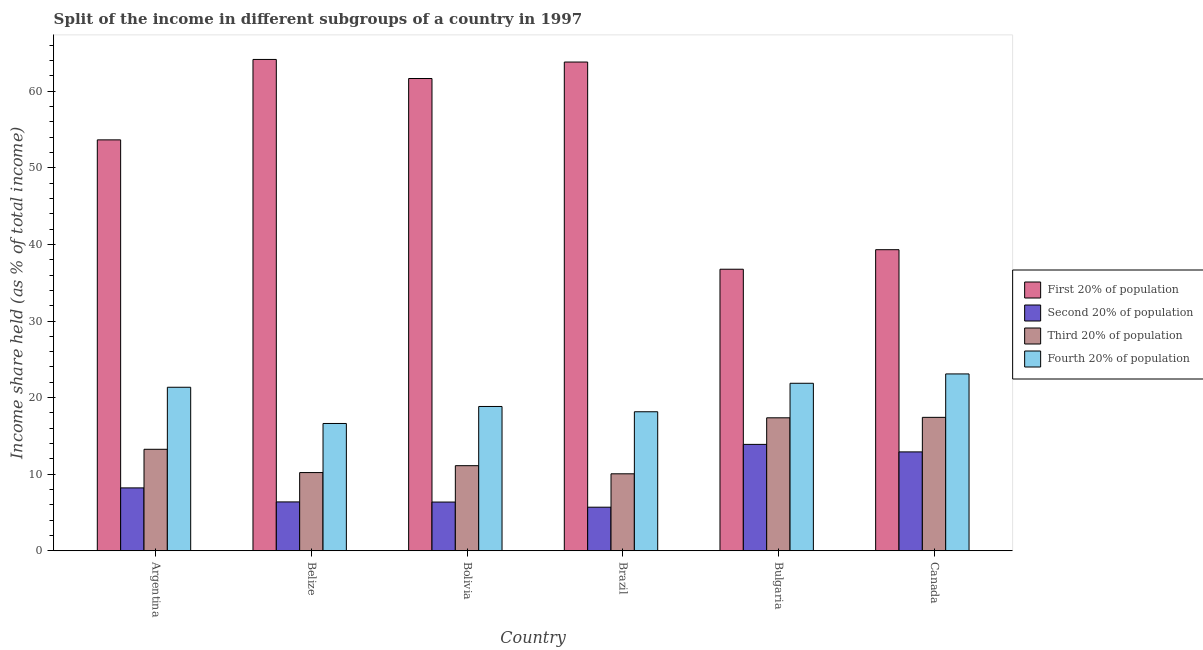How many different coloured bars are there?
Provide a succinct answer. 4. How many groups of bars are there?
Your answer should be compact. 6. How many bars are there on the 5th tick from the right?
Offer a very short reply. 4. What is the share of the income held by first 20% of the population in Brazil?
Ensure brevity in your answer.  63.81. Across all countries, what is the maximum share of the income held by fourth 20% of the population?
Ensure brevity in your answer.  23.09. Across all countries, what is the minimum share of the income held by third 20% of the population?
Your answer should be very brief. 10.05. What is the total share of the income held by third 20% of the population in the graph?
Keep it short and to the point. 79.4. What is the difference between the share of the income held by first 20% of the population in Argentina and that in Bulgaria?
Provide a succinct answer. 16.89. What is the difference between the share of the income held by fourth 20% of the population in Argentina and the share of the income held by third 20% of the population in Canada?
Provide a succinct answer. 3.93. What is the average share of the income held by first 20% of the population per country?
Keep it short and to the point. 53.22. What is the difference between the share of the income held by third 20% of the population and share of the income held by fourth 20% of the population in Bulgaria?
Ensure brevity in your answer.  -4.51. In how many countries, is the share of the income held by third 20% of the population greater than 50 %?
Your response must be concise. 0. What is the ratio of the share of the income held by third 20% of the population in Belize to that in Canada?
Your response must be concise. 0.59. What is the difference between the highest and the second highest share of the income held by fourth 20% of the population?
Your answer should be very brief. 1.22. What is the difference between the highest and the lowest share of the income held by third 20% of the population?
Your answer should be very brief. 7.37. In how many countries, is the share of the income held by first 20% of the population greater than the average share of the income held by first 20% of the population taken over all countries?
Offer a very short reply. 4. Is the sum of the share of the income held by fourth 20% of the population in Argentina and Brazil greater than the maximum share of the income held by third 20% of the population across all countries?
Make the answer very short. Yes. What does the 3rd bar from the left in Belize represents?
Make the answer very short. Third 20% of population. What does the 4th bar from the right in Canada represents?
Your answer should be compact. First 20% of population. Is it the case that in every country, the sum of the share of the income held by first 20% of the population and share of the income held by second 20% of the population is greater than the share of the income held by third 20% of the population?
Provide a short and direct response. Yes. Are all the bars in the graph horizontal?
Give a very brief answer. No. How many countries are there in the graph?
Your response must be concise. 6. What is the difference between two consecutive major ticks on the Y-axis?
Make the answer very short. 10. Are the values on the major ticks of Y-axis written in scientific E-notation?
Offer a terse response. No. Does the graph contain any zero values?
Offer a very short reply. No. Does the graph contain grids?
Keep it short and to the point. No. Where does the legend appear in the graph?
Keep it short and to the point. Center right. How many legend labels are there?
Give a very brief answer. 4. How are the legend labels stacked?
Offer a terse response. Vertical. What is the title of the graph?
Your answer should be compact. Split of the income in different subgroups of a country in 1997. Does "Luxembourg" appear as one of the legend labels in the graph?
Your answer should be very brief. No. What is the label or title of the Y-axis?
Make the answer very short. Income share held (as % of total income). What is the Income share held (as % of total income) of First 20% of population in Argentina?
Provide a succinct answer. 53.65. What is the Income share held (as % of total income) in Second 20% of population in Argentina?
Make the answer very short. 8.21. What is the Income share held (as % of total income) in Third 20% of population in Argentina?
Keep it short and to the point. 13.25. What is the Income share held (as % of total income) in Fourth 20% of population in Argentina?
Offer a very short reply. 21.35. What is the Income share held (as % of total income) in First 20% of population in Belize?
Provide a succinct answer. 64.15. What is the Income share held (as % of total income) of Second 20% of population in Belize?
Offer a terse response. 6.38. What is the Income share held (as % of total income) of Third 20% of population in Belize?
Keep it short and to the point. 10.21. What is the Income share held (as % of total income) in Fourth 20% of population in Belize?
Ensure brevity in your answer.  16.62. What is the Income share held (as % of total income) of First 20% of population in Bolivia?
Offer a very short reply. 61.66. What is the Income share held (as % of total income) in Second 20% of population in Bolivia?
Your answer should be compact. 6.36. What is the Income share held (as % of total income) in Third 20% of population in Bolivia?
Offer a very short reply. 11.11. What is the Income share held (as % of total income) in Fourth 20% of population in Bolivia?
Give a very brief answer. 18.84. What is the Income share held (as % of total income) in First 20% of population in Brazil?
Keep it short and to the point. 63.81. What is the Income share held (as % of total income) in Second 20% of population in Brazil?
Make the answer very short. 5.69. What is the Income share held (as % of total income) of Third 20% of population in Brazil?
Offer a very short reply. 10.05. What is the Income share held (as % of total income) in Fourth 20% of population in Brazil?
Your answer should be very brief. 18.15. What is the Income share held (as % of total income) in First 20% of population in Bulgaria?
Offer a very short reply. 36.76. What is the Income share held (as % of total income) in Second 20% of population in Bulgaria?
Make the answer very short. 13.89. What is the Income share held (as % of total income) in Third 20% of population in Bulgaria?
Provide a succinct answer. 17.36. What is the Income share held (as % of total income) of Fourth 20% of population in Bulgaria?
Give a very brief answer. 21.87. What is the Income share held (as % of total income) in First 20% of population in Canada?
Your answer should be compact. 39.31. What is the Income share held (as % of total income) in Second 20% of population in Canada?
Offer a terse response. 12.91. What is the Income share held (as % of total income) of Third 20% of population in Canada?
Your answer should be compact. 17.42. What is the Income share held (as % of total income) of Fourth 20% of population in Canada?
Offer a very short reply. 23.09. Across all countries, what is the maximum Income share held (as % of total income) of First 20% of population?
Keep it short and to the point. 64.15. Across all countries, what is the maximum Income share held (as % of total income) in Second 20% of population?
Your answer should be very brief. 13.89. Across all countries, what is the maximum Income share held (as % of total income) in Third 20% of population?
Your answer should be very brief. 17.42. Across all countries, what is the maximum Income share held (as % of total income) of Fourth 20% of population?
Ensure brevity in your answer.  23.09. Across all countries, what is the minimum Income share held (as % of total income) in First 20% of population?
Keep it short and to the point. 36.76. Across all countries, what is the minimum Income share held (as % of total income) in Second 20% of population?
Make the answer very short. 5.69. Across all countries, what is the minimum Income share held (as % of total income) in Third 20% of population?
Provide a short and direct response. 10.05. Across all countries, what is the minimum Income share held (as % of total income) in Fourth 20% of population?
Provide a succinct answer. 16.62. What is the total Income share held (as % of total income) of First 20% of population in the graph?
Your response must be concise. 319.34. What is the total Income share held (as % of total income) of Second 20% of population in the graph?
Your answer should be compact. 53.44. What is the total Income share held (as % of total income) in Third 20% of population in the graph?
Your response must be concise. 79.4. What is the total Income share held (as % of total income) of Fourth 20% of population in the graph?
Your answer should be compact. 119.92. What is the difference between the Income share held (as % of total income) in First 20% of population in Argentina and that in Belize?
Your answer should be compact. -10.5. What is the difference between the Income share held (as % of total income) in Second 20% of population in Argentina and that in Belize?
Provide a short and direct response. 1.83. What is the difference between the Income share held (as % of total income) of Third 20% of population in Argentina and that in Belize?
Your response must be concise. 3.04. What is the difference between the Income share held (as % of total income) in Fourth 20% of population in Argentina and that in Belize?
Keep it short and to the point. 4.73. What is the difference between the Income share held (as % of total income) in First 20% of population in Argentina and that in Bolivia?
Your response must be concise. -8.01. What is the difference between the Income share held (as % of total income) of Second 20% of population in Argentina and that in Bolivia?
Give a very brief answer. 1.85. What is the difference between the Income share held (as % of total income) of Third 20% of population in Argentina and that in Bolivia?
Keep it short and to the point. 2.14. What is the difference between the Income share held (as % of total income) in Fourth 20% of population in Argentina and that in Bolivia?
Give a very brief answer. 2.51. What is the difference between the Income share held (as % of total income) in First 20% of population in Argentina and that in Brazil?
Offer a terse response. -10.16. What is the difference between the Income share held (as % of total income) of Second 20% of population in Argentina and that in Brazil?
Offer a very short reply. 2.52. What is the difference between the Income share held (as % of total income) of First 20% of population in Argentina and that in Bulgaria?
Give a very brief answer. 16.89. What is the difference between the Income share held (as % of total income) in Second 20% of population in Argentina and that in Bulgaria?
Offer a very short reply. -5.68. What is the difference between the Income share held (as % of total income) in Third 20% of population in Argentina and that in Bulgaria?
Make the answer very short. -4.11. What is the difference between the Income share held (as % of total income) of Fourth 20% of population in Argentina and that in Bulgaria?
Give a very brief answer. -0.52. What is the difference between the Income share held (as % of total income) in First 20% of population in Argentina and that in Canada?
Your answer should be very brief. 14.34. What is the difference between the Income share held (as % of total income) in Third 20% of population in Argentina and that in Canada?
Keep it short and to the point. -4.17. What is the difference between the Income share held (as % of total income) in Fourth 20% of population in Argentina and that in Canada?
Your response must be concise. -1.74. What is the difference between the Income share held (as % of total income) in First 20% of population in Belize and that in Bolivia?
Ensure brevity in your answer.  2.49. What is the difference between the Income share held (as % of total income) in Fourth 20% of population in Belize and that in Bolivia?
Your answer should be compact. -2.22. What is the difference between the Income share held (as % of total income) of First 20% of population in Belize and that in Brazil?
Offer a very short reply. 0.34. What is the difference between the Income share held (as % of total income) of Second 20% of population in Belize and that in Brazil?
Your answer should be very brief. 0.69. What is the difference between the Income share held (as % of total income) in Third 20% of population in Belize and that in Brazil?
Make the answer very short. 0.16. What is the difference between the Income share held (as % of total income) in Fourth 20% of population in Belize and that in Brazil?
Offer a terse response. -1.53. What is the difference between the Income share held (as % of total income) in First 20% of population in Belize and that in Bulgaria?
Give a very brief answer. 27.39. What is the difference between the Income share held (as % of total income) of Second 20% of population in Belize and that in Bulgaria?
Give a very brief answer. -7.51. What is the difference between the Income share held (as % of total income) of Third 20% of population in Belize and that in Bulgaria?
Provide a short and direct response. -7.15. What is the difference between the Income share held (as % of total income) of Fourth 20% of population in Belize and that in Bulgaria?
Provide a short and direct response. -5.25. What is the difference between the Income share held (as % of total income) of First 20% of population in Belize and that in Canada?
Provide a short and direct response. 24.84. What is the difference between the Income share held (as % of total income) of Second 20% of population in Belize and that in Canada?
Offer a terse response. -6.53. What is the difference between the Income share held (as % of total income) in Third 20% of population in Belize and that in Canada?
Your response must be concise. -7.21. What is the difference between the Income share held (as % of total income) in Fourth 20% of population in Belize and that in Canada?
Keep it short and to the point. -6.47. What is the difference between the Income share held (as % of total income) of First 20% of population in Bolivia and that in Brazil?
Offer a very short reply. -2.15. What is the difference between the Income share held (as % of total income) of Second 20% of population in Bolivia and that in Brazil?
Your answer should be compact. 0.67. What is the difference between the Income share held (as % of total income) of Third 20% of population in Bolivia and that in Brazil?
Give a very brief answer. 1.06. What is the difference between the Income share held (as % of total income) in Fourth 20% of population in Bolivia and that in Brazil?
Keep it short and to the point. 0.69. What is the difference between the Income share held (as % of total income) of First 20% of population in Bolivia and that in Bulgaria?
Give a very brief answer. 24.9. What is the difference between the Income share held (as % of total income) of Second 20% of population in Bolivia and that in Bulgaria?
Offer a very short reply. -7.53. What is the difference between the Income share held (as % of total income) in Third 20% of population in Bolivia and that in Bulgaria?
Offer a very short reply. -6.25. What is the difference between the Income share held (as % of total income) of Fourth 20% of population in Bolivia and that in Bulgaria?
Keep it short and to the point. -3.03. What is the difference between the Income share held (as % of total income) of First 20% of population in Bolivia and that in Canada?
Your response must be concise. 22.35. What is the difference between the Income share held (as % of total income) of Second 20% of population in Bolivia and that in Canada?
Your answer should be compact. -6.55. What is the difference between the Income share held (as % of total income) of Third 20% of population in Bolivia and that in Canada?
Provide a succinct answer. -6.31. What is the difference between the Income share held (as % of total income) in Fourth 20% of population in Bolivia and that in Canada?
Provide a short and direct response. -4.25. What is the difference between the Income share held (as % of total income) in First 20% of population in Brazil and that in Bulgaria?
Offer a very short reply. 27.05. What is the difference between the Income share held (as % of total income) of Second 20% of population in Brazil and that in Bulgaria?
Ensure brevity in your answer.  -8.2. What is the difference between the Income share held (as % of total income) in Third 20% of population in Brazil and that in Bulgaria?
Give a very brief answer. -7.31. What is the difference between the Income share held (as % of total income) in Fourth 20% of population in Brazil and that in Bulgaria?
Your answer should be very brief. -3.72. What is the difference between the Income share held (as % of total income) of Second 20% of population in Brazil and that in Canada?
Make the answer very short. -7.22. What is the difference between the Income share held (as % of total income) of Third 20% of population in Brazil and that in Canada?
Provide a succinct answer. -7.37. What is the difference between the Income share held (as % of total income) in Fourth 20% of population in Brazil and that in Canada?
Provide a succinct answer. -4.94. What is the difference between the Income share held (as % of total income) of First 20% of population in Bulgaria and that in Canada?
Provide a short and direct response. -2.55. What is the difference between the Income share held (as % of total income) in Second 20% of population in Bulgaria and that in Canada?
Make the answer very short. 0.98. What is the difference between the Income share held (as % of total income) of Third 20% of population in Bulgaria and that in Canada?
Your answer should be compact. -0.06. What is the difference between the Income share held (as % of total income) in Fourth 20% of population in Bulgaria and that in Canada?
Provide a succinct answer. -1.22. What is the difference between the Income share held (as % of total income) of First 20% of population in Argentina and the Income share held (as % of total income) of Second 20% of population in Belize?
Offer a very short reply. 47.27. What is the difference between the Income share held (as % of total income) in First 20% of population in Argentina and the Income share held (as % of total income) in Third 20% of population in Belize?
Give a very brief answer. 43.44. What is the difference between the Income share held (as % of total income) in First 20% of population in Argentina and the Income share held (as % of total income) in Fourth 20% of population in Belize?
Offer a very short reply. 37.03. What is the difference between the Income share held (as % of total income) of Second 20% of population in Argentina and the Income share held (as % of total income) of Fourth 20% of population in Belize?
Your answer should be very brief. -8.41. What is the difference between the Income share held (as % of total income) of Third 20% of population in Argentina and the Income share held (as % of total income) of Fourth 20% of population in Belize?
Keep it short and to the point. -3.37. What is the difference between the Income share held (as % of total income) in First 20% of population in Argentina and the Income share held (as % of total income) in Second 20% of population in Bolivia?
Provide a succinct answer. 47.29. What is the difference between the Income share held (as % of total income) of First 20% of population in Argentina and the Income share held (as % of total income) of Third 20% of population in Bolivia?
Provide a succinct answer. 42.54. What is the difference between the Income share held (as % of total income) of First 20% of population in Argentina and the Income share held (as % of total income) of Fourth 20% of population in Bolivia?
Provide a short and direct response. 34.81. What is the difference between the Income share held (as % of total income) of Second 20% of population in Argentina and the Income share held (as % of total income) of Fourth 20% of population in Bolivia?
Offer a very short reply. -10.63. What is the difference between the Income share held (as % of total income) of Third 20% of population in Argentina and the Income share held (as % of total income) of Fourth 20% of population in Bolivia?
Your response must be concise. -5.59. What is the difference between the Income share held (as % of total income) of First 20% of population in Argentina and the Income share held (as % of total income) of Second 20% of population in Brazil?
Make the answer very short. 47.96. What is the difference between the Income share held (as % of total income) in First 20% of population in Argentina and the Income share held (as % of total income) in Third 20% of population in Brazil?
Your answer should be compact. 43.6. What is the difference between the Income share held (as % of total income) of First 20% of population in Argentina and the Income share held (as % of total income) of Fourth 20% of population in Brazil?
Offer a very short reply. 35.5. What is the difference between the Income share held (as % of total income) in Second 20% of population in Argentina and the Income share held (as % of total income) in Third 20% of population in Brazil?
Provide a short and direct response. -1.84. What is the difference between the Income share held (as % of total income) in Second 20% of population in Argentina and the Income share held (as % of total income) in Fourth 20% of population in Brazil?
Offer a terse response. -9.94. What is the difference between the Income share held (as % of total income) of Third 20% of population in Argentina and the Income share held (as % of total income) of Fourth 20% of population in Brazil?
Provide a succinct answer. -4.9. What is the difference between the Income share held (as % of total income) in First 20% of population in Argentina and the Income share held (as % of total income) in Second 20% of population in Bulgaria?
Keep it short and to the point. 39.76. What is the difference between the Income share held (as % of total income) in First 20% of population in Argentina and the Income share held (as % of total income) in Third 20% of population in Bulgaria?
Ensure brevity in your answer.  36.29. What is the difference between the Income share held (as % of total income) of First 20% of population in Argentina and the Income share held (as % of total income) of Fourth 20% of population in Bulgaria?
Offer a very short reply. 31.78. What is the difference between the Income share held (as % of total income) in Second 20% of population in Argentina and the Income share held (as % of total income) in Third 20% of population in Bulgaria?
Provide a succinct answer. -9.15. What is the difference between the Income share held (as % of total income) of Second 20% of population in Argentina and the Income share held (as % of total income) of Fourth 20% of population in Bulgaria?
Give a very brief answer. -13.66. What is the difference between the Income share held (as % of total income) in Third 20% of population in Argentina and the Income share held (as % of total income) in Fourth 20% of population in Bulgaria?
Your answer should be very brief. -8.62. What is the difference between the Income share held (as % of total income) in First 20% of population in Argentina and the Income share held (as % of total income) in Second 20% of population in Canada?
Your response must be concise. 40.74. What is the difference between the Income share held (as % of total income) of First 20% of population in Argentina and the Income share held (as % of total income) of Third 20% of population in Canada?
Ensure brevity in your answer.  36.23. What is the difference between the Income share held (as % of total income) in First 20% of population in Argentina and the Income share held (as % of total income) in Fourth 20% of population in Canada?
Make the answer very short. 30.56. What is the difference between the Income share held (as % of total income) of Second 20% of population in Argentina and the Income share held (as % of total income) of Third 20% of population in Canada?
Your answer should be very brief. -9.21. What is the difference between the Income share held (as % of total income) in Second 20% of population in Argentina and the Income share held (as % of total income) in Fourth 20% of population in Canada?
Give a very brief answer. -14.88. What is the difference between the Income share held (as % of total income) of Third 20% of population in Argentina and the Income share held (as % of total income) of Fourth 20% of population in Canada?
Provide a short and direct response. -9.84. What is the difference between the Income share held (as % of total income) in First 20% of population in Belize and the Income share held (as % of total income) in Second 20% of population in Bolivia?
Give a very brief answer. 57.79. What is the difference between the Income share held (as % of total income) in First 20% of population in Belize and the Income share held (as % of total income) in Third 20% of population in Bolivia?
Your response must be concise. 53.04. What is the difference between the Income share held (as % of total income) of First 20% of population in Belize and the Income share held (as % of total income) of Fourth 20% of population in Bolivia?
Offer a very short reply. 45.31. What is the difference between the Income share held (as % of total income) of Second 20% of population in Belize and the Income share held (as % of total income) of Third 20% of population in Bolivia?
Make the answer very short. -4.73. What is the difference between the Income share held (as % of total income) in Second 20% of population in Belize and the Income share held (as % of total income) in Fourth 20% of population in Bolivia?
Keep it short and to the point. -12.46. What is the difference between the Income share held (as % of total income) of Third 20% of population in Belize and the Income share held (as % of total income) of Fourth 20% of population in Bolivia?
Keep it short and to the point. -8.63. What is the difference between the Income share held (as % of total income) of First 20% of population in Belize and the Income share held (as % of total income) of Second 20% of population in Brazil?
Your answer should be compact. 58.46. What is the difference between the Income share held (as % of total income) of First 20% of population in Belize and the Income share held (as % of total income) of Third 20% of population in Brazil?
Ensure brevity in your answer.  54.1. What is the difference between the Income share held (as % of total income) of First 20% of population in Belize and the Income share held (as % of total income) of Fourth 20% of population in Brazil?
Keep it short and to the point. 46. What is the difference between the Income share held (as % of total income) in Second 20% of population in Belize and the Income share held (as % of total income) in Third 20% of population in Brazil?
Keep it short and to the point. -3.67. What is the difference between the Income share held (as % of total income) of Second 20% of population in Belize and the Income share held (as % of total income) of Fourth 20% of population in Brazil?
Provide a succinct answer. -11.77. What is the difference between the Income share held (as % of total income) of Third 20% of population in Belize and the Income share held (as % of total income) of Fourth 20% of population in Brazil?
Offer a very short reply. -7.94. What is the difference between the Income share held (as % of total income) of First 20% of population in Belize and the Income share held (as % of total income) of Second 20% of population in Bulgaria?
Provide a short and direct response. 50.26. What is the difference between the Income share held (as % of total income) in First 20% of population in Belize and the Income share held (as % of total income) in Third 20% of population in Bulgaria?
Provide a succinct answer. 46.79. What is the difference between the Income share held (as % of total income) in First 20% of population in Belize and the Income share held (as % of total income) in Fourth 20% of population in Bulgaria?
Give a very brief answer. 42.28. What is the difference between the Income share held (as % of total income) of Second 20% of population in Belize and the Income share held (as % of total income) of Third 20% of population in Bulgaria?
Offer a very short reply. -10.98. What is the difference between the Income share held (as % of total income) in Second 20% of population in Belize and the Income share held (as % of total income) in Fourth 20% of population in Bulgaria?
Provide a succinct answer. -15.49. What is the difference between the Income share held (as % of total income) of Third 20% of population in Belize and the Income share held (as % of total income) of Fourth 20% of population in Bulgaria?
Make the answer very short. -11.66. What is the difference between the Income share held (as % of total income) in First 20% of population in Belize and the Income share held (as % of total income) in Second 20% of population in Canada?
Give a very brief answer. 51.24. What is the difference between the Income share held (as % of total income) in First 20% of population in Belize and the Income share held (as % of total income) in Third 20% of population in Canada?
Provide a short and direct response. 46.73. What is the difference between the Income share held (as % of total income) in First 20% of population in Belize and the Income share held (as % of total income) in Fourth 20% of population in Canada?
Provide a succinct answer. 41.06. What is the difference between the Income share held (as % of total income) of Second 20% of population in Belize and the Income share held (as % of total income) of Third 20% of population in Canada?
Keep it short and to the point. -11.04. What is the difference between the Income share held (as % of total income) of Second 20% of population in Belize and the Income share held (as % of total income) of Fourth 20% of population in Canada?
Keep it short and to the point. -16.71. What is the difference between the Income share held (as % of total income) of Third 20% of population in Belize and the Income share held (as % of total income) of Fourth 20% of population in Canada?
Your answer should be very brief. -12.88. What is the difference between the Income share held (as % of total income) of First 20% of population in Bolivia and the Income share held (as % of total income) of Second 20% of population in Brazil?
Your answer should be compact. 55.97. What is the difference between the Income share held (as % of total income) in First 20% of population in Bolivia and the Income share held (as % of total income) in Third 20% of population in Brazil?
Your response must be concise. 51.61. What is the difference between the Income share held (as % of total income) in First 20% of population in Bolivia and the Income share held (as % of total income) in Fourth 20% of population in Brazil?
Keep it short and to the point. 43.51. What is the difference between the Income share held (as % of total income) of Second 20% of population in Bolivia and the Income share held (as % of total income) of Third 20% of population in Brazil?
Make the answer very short. -3.69. What is the difference between the Income share held (as % of total income) in Second 20% of population in Bolivia and the Income share held (as % of total income) in Fourth 20% of population in Brazil?
Your answer should be compact. -11.79. What is the difference between the Income share held (as % of total income) of Third 20% of population in Bolivia and the Income share held (as % of total income) of Fourth 20% of population in Brazil?
Keep it short and to the point. -7.04. What is the difference between the Income share held (as % of total income) of First 20% of population in Bolivia and the Income share held (as % of total income) of Second 20% of population in Bulgaria?
Offer a very short reply. 47.77. What is the difference between the Income share held (as % of total income) of First 20% of population in Bolivia and the Income share held (as % of total income) of Third 20% of population in Bulgaria?
Offer a very short reply. 44.3. What is the difference between the Income share held (as % of total income) in First 20% of population in Bolivia and the Income share held (as % of total income) in Fourth 20% of population in Bulgaria?
Your answer should be very brief. 39.79. What is the difference between the Income share held (as % of total income) in Second 20% of population in Bolivia and the Income share held (as % of total income) in Fourth 20% of population in Bulgaria?
Keep it short and to the point. -15.51. What is the difference between the Income share held (as % of total income) in Third 20% of population in Bolivia and the Income share held (as % of total income) in Fourth 20% of population in Bulgaria?
Provide a succinct answer. -10.76. What is the difference between the Income share held (as % of total income) in First 20% of population in Bolivia and the Income share held (as % of total income) in Second 20% of population in Canada?
Provide a succinct answer. 48.75. What is the difference between the Income share held (as % of total income) in First 20% of population in Bolivia and the Income share held (as % of total income) in Third 20% of population in Canada?
Ensure brevity in your answer.  44.24. What is the difference between the Income share held (as % of total income) of First 20% of population in Bolivia and the Income share held (as % of total income) of Fourth 20% of population in Canada?
Make the answer very short. 38.57. What is the difference between the Income share held (as % of total income) of Second 20% of population in Bolivia and the Income share held (as % of total income) of Third 20% of population in Canada?
Ensure brevity in your answer.  -11.06. What is the difference between the Income share held (as % of total income) in Second 20% of population in Bolivia and the Income share held (as % of total income) in Fourth 20% of population in Canada?
Offer a terse response. -16.73. What is the difference between the Income share held (as % of total income) of Third 20% of population in Bolivia and the Income share held (as % of total income) of Fourth 20% of population in Canada?
Your response must be concise. -11.98. What is the difference between the Income share held (as % of total income) of First 20% of population in Brazil and the Income share held (as % of total income) of Second 20% of population in Bulgaria?
Keep it short and to the point. 49.92. What is the difference between the Income share held (as % of total income) of First 20% of population in Brazil and the Income share held (as % of total income) of Third 20% of population in Bulgaria?
Your response must be concise. 46.45. What is the difference between the Income share held (as % of total income) in First 20% of population in Brazil and the Income share held (as % of total income) in Fourth 20% of population in Bulgaria?
Keep it short and to the point. 41.94. What is the difference between the Income share held (as % of total income) of Second 20% of population in Brazil and the Income share held (as % of total income) of Third 20% of population in Bulgaria?
Make the answer very short. -11.67. What is the difference between the Income share held (as % of total income) of Second 20% of population in Brazil and the Income share held (as % of total income) of Fourth 20% of population in Bulgaria?
Give a very brief answer. -16.18. What is the difference between the Income share held (as % of total income) in Third 20% of population in Brazil and the Income share held (as % of total income) in Fourth 20% of population in Bulgaria?
Ensure brevity in your answer.  -11.82. What is the difference between the Income share held (as % of total income) of First 20% of population in Brazil and the Income share held (as % of total income) of Second 20% of population in Canada?
Offer a terse response. 50.9. What is the difference between the Income share held (as % of total income) of First 20% of population in Brazil and the Income share held (as % of total income) of Third 20% of population in Canada?
Provide a succinct answer. 46.39. What is the difference between the Income share held (as % of total income) in First 20% of population in Brazil and the Income share held (as % of total income) in Fourth 20% of population in Canada?
Give a very brief answer. 40.72. What is the difference between the Income share held (as % of total income) in Second 20% of population in Brazil and the Income share held (as % of total income) in Third 20% of population in Canada?
Give a very brief answer. -11.73. What is the difference between the Income share held (as % of total income) in Second 20% of population in Brazil and the Income share held (as % of total income) in Fourth 20% of population in Canada?
Offer a very short reply. -17.4. What is the difference between the Income share held (as % of total income) in Third 20% of population in Brazil and the Income share held (as % of total income) in Fourth 20% of population in Canada?
Keep it short and to the point. -13.04. What is the difference between the Income share held (as % of total income) in First 20% of population in Bulgaria and the Income share held (as % of total income) in Second 20% of population in Canada?
Your answer should be very brief. 23.85. What is the difference between the Income share held (as % of total income) in First 20% of population in Bulgaria and the Income share held (as % of total income) in Third 20% of population in Canada?
Your response must be concise. 19.34. What is the difference between the Income share held (as % of total income) in First 20% of population in Bulgaria and the Income share held (as % of total income) in Fourth 20% of population in Canada?
Make the answer very short. 13.67. What is the difference between the Income share held (as % of total income) of Second 20% of population in Bulgaria and the Income share held (as % of total income) of Third 20% of population in Canada?
Keep it short and to the point. -3.53. What is the difference between the Income share held (as % of total income) in Third 20% of population in Bulgaria and the Income share held (as % of total income) in Fourth 20% of population in Canada?
Your answer should be very brief. -5.73. What is the average Income share held (as % of total income) of First 20% of population per country?
Provide a short and direct response. 53.22. What is the average Income share held (as % of total income) of Second 20% of population per country?
Offer a terse response. 8.91. What is the average Income share held (as % of total income) of Third 20% of population per country?
Offer a terse response. 13.23. What is the average Income share held (as % of total income) in Fourth 20% of population per country?
Provide a succinct answer. 19.99. What is the difference between the Income share held (as % of total income) in First 20% of population and Income share held (as % of total income) in Second 20% of population in Argentina?
Your response must be concise. 45.44. What is the difference between the Income share held (as % of total income) of First 20% of population and Income share held (as % of total income) of Third 20% of population in Argentina?
Your response must be concise. 40.4. What is the difference between the Income share held (as % of total income) in First 20% of population and Income share held (as % of total income) in Fourth 20% of population in Argentina?
Your response must be concise. 32.3. What is the difference between the Income share held (as % of total income) of Second 20% of population and Income share held (as % of total income) of Third 20% of population in Argentina?
Offer a terse response. -5.04. What is the difference between the Income share held (as % of total income) of Second 20% of population and Income share held (as % of total income) of Fourth 20% of population in Argentina?
Your answer should be compact. -13.14. What is the difference between the Income share held (as % of total income) of First 20% of population and Income share held (as % of total income) of Second 20% of population in Belize?
Your answer should be very brief. 57.77. What is the difference between the Income share held (as % of total income) of First 20% of population and Income share held (as % of total income) of Third 20% of population in Belize?
Your answer should be very brief. 53.94. What is the difference between the Income share held (as % of total income) of First 20% of population and Income share held (as % of total income) of Fourth 20% of population in Belize?
Keep it short and to the point. 47.53. What is the difference between the Income share held (as % of total income) in Second 20% of population and Income share held (as % of total income) in Third 20% of population in Belize?
Make the answer very short. -3.83. What is the difference between the Income share held (as % of total income) of Second 20% of population and Income share held (as % of total income) of Fourth 20% of population in Belize?
Give a very brief answer. -10.24. What is the difference between the Income share held (as % of total income) of Third 20% of population and Income share held (as % of total income) of Fourth 20% of population in Belize?
Ensure brevity in your answer.  -6.41. What is the difference between the Income share held (as % of total income) in First 20% of population and Income share held (as % of total income) in Second 20% of population in Bolivia?
Your answer should be very brief. 55.3. What is the difference between the Income share held (as % of total income) in First 20% of population and Income share held (as % of total income) in Third 20% of population in Bolivia?
Give a very brief answer. 50.55. What is the difference between the Income share held (as % of total income) in First 20% of population and Income share held (as % of total income) in Fourth 20% of population in Bolivia?
Offer a terse response. 42.82. What is the difference between the Income share held (as % of total income) of Second 20% of population and Income share held (as % of total income) of Third 20% of population in Bolivia?
Your answer should be very brief. -4.75. What is the difference between the Income share held (as % of total income) of Second 20% of population and Income share held (as % of total income) of Fourth 20% of population in Bolivia?
Your answer should be compact. -12.48. What is the difference between the Income share held (as % of total income) in Third 20% of population and Income share held (as % of total income) in Fourth 20% of population in Bolivia?
Keep it short and to the point. -7.73. What is the difference between the Income share held (as % of total income) of First 20% of population and Income share held (as % of total income) of Second 20% of population in Brazil?
Your answer should be compact. 58.12. What is the difference between the Income share held (as % of total income) in First 20% of population and Income share held (as % of total income) in Third 20% of population in Brazil?
Provide a succinct answer. 53.76. What is the difference between the Income share held (as % of total income) of First 20% of population and Income share held (as % of total income) of Fourth 20% of population in Brazil?
Offer a terse response. 45.66. What is the difference between the Income share held (as % of total income) of Second 20% of population and Income share held (as % of total income) of Third 20% of population in Brazil?
Ensure brevity in your answer.  -4.36. What is the difference between the Income share held (as % of total income) in Second 20% of population and Income share held (as % of total income) in Fourth 20% of population in Brazil?
Offer a very short reply. -12.46. What is the difference between the Income share held (as % of total income) in First 20% of population and Income share held (as % of total income) in Second 20% of population in Bulgaria?
Offer a terse response. 22.87. What is the difference between the Income share held (as % of total income) of First 20% of population and Income share held (as % of total income) of Third 20% of population in Bulgaria?
Give a very brief answer. 19.4. What is the difference between the Income share held (as % of total income) of First 20% of population and Income share held (as % of total income) of Fourth 20% of population in Bulgaria?
Keep it short and to the point. 14.89. What is the difference between the Income share held (as % of total income) in Second 20% of population and Income share held (as % of total income) in Third 20% of population in Bulgaria?
Offer a terse response. -3.47. What is the difference between the Income share held (as % of total income) in Second 20% of population and Income share held (as % of total income) in Fourth 20% of population in Bulgaria?
Provide a short and direct response. -7.98. What is the difference between the Income share held (as % of total income) in Third 20% of population and Income share held (as % of total income) in Fourth 20% of population in Bulgaria?
Your answer should be very brief. -4.51. What is the difference between the Income share held (as % of total income) of First 20% of population and Income share held (as % of total income) of Second 20% of population in Canada?
Provide a succinct answer. 26.4. What is the difference between the Income share held (as % of total income) of First 20% of population and Income share held (as % of total income) of Third 20% of population in Canada?
Make the answer very short. 21.89. What is the difference between the Income share held (as % of total income) in First 20% of population and Income share held (as % of total income) in Fourth 20% of population in Canada?
Give a very brief answer. 16.22. What is the difference between the Income share held (as % of total income) of Second 20% of population and Income share held (as % of total income) of Third 20% of population in Canada?
Your answer should be compact. -4.51. What is the difference between the Income share held (as % of total income) in Second 20% of population and Income share held (as % of total income) in Fourth 20% of population in Canada?
Provide a succinct answer. -10.18. What is the difference between the Income share held (as % of total income) in Third 20% of population and Income share held (as % of total income) in Fourth 20% of population in Canada?
Keep it short and to the point. -5.67. What is the ratio of the Income share held (as % of total income) in First 20% of population in Argentina to that in Belize?
Make the answer very short. 0.84. What is the ratio of the Income share held (as % of total income) in Second 20% of population in Argentina to that in Belize?
Keep it short and to the point. 1.29. What is the ratio of the Income share held (as % of total income) of Third 20% of population in Argentina to that in Belize?
Ensure brevity in your answer.  1.3. What is the ratio of the Income share held (as % of total income) in Fourth 20% of population in Argentina to that in Belize?
Offer a terse response. 1.28. What is the ratio of the Income share held (as % of total income) in First 20% of population in Argentina to that in Bolivia?
Make the answer very short. 0.87. What is the ratio of the Income share held (as % of total income) in Second 20% of population in Argentina to that in Bolivia?
Your answer should be compact. 1.29. What is the ratio of the Income share held (as % of total income) of Third 20% of population in Argentina to that in Bolivia?
Make the answer very short. 1.19. What is the ratio of the Income share held (as % of total income) of Fourth 20% of population in Argentina to that in Bolivia?
Your answer should be compact. 1.13. What is the ratio of the Income share held (as % of total income) in First 20% of population in Argentina to that in Brazil?
Your answer should be very brief. 0.84. What is the ratio of the Income share held (as % of total income) in Second 20% of population in Argentina to that in Brazil?
Your answer should be compact. 1.44. What is the ratio of the Income share held (as % of total income) of Third 20% of population in Argentina to that in Brazil?
Provide a short and direct response. 1.32. What is the ratio of the Income share held (as % of total income) of Fourth 20% of population in Argentina to that in Brazil?
Keep it short and to the point. 1.18. What is the ratio of the Income share held (as % of total income) in First 20% of population in Argentina to that in Bulgaria?
Make the answer very short. 1.46. What is the ratio of the Income share held (as % of total income) in Second 20% of population in Argentina to that in Bulgaria?
Your answer should be compact. 0.59. What is the ratio of the Income share held (as % of total income) in Third 20% of population in Argentina to that in Bulgaria?
Offer a terse response. 0.76. What is the ratio of the Income share held (as % of total income) of Fourth 20% of population in Argentina to that in Bulgaria?
Offer a terse response. 0.98. What is the ratio of the Income share held (as % of total income) in First 20% of population in Argentina to that in Canada?
Offer a terse response. 1.36. What is the ratio of the Income share held (as % of total income) of Second 20% of population in Argentina to that in Canada?
Your answer should be very brief. 0.64. What is the ratio of the Income share held (as % of total income) of Third 20% of population in Argentina to that in Canada?
Provide a succinct answer. 0.76. What is the ratio of the Income share held (as % of total income) of Fourth 20% of population in Argentina to that in Canada?
Ensure brevity in your answer.  0.92. What is the ratio of the Income share held (as % of total income) in First 20% of population in Belize to that in Bolivia?
Offer a very short reply. 1.04. What is the ratio of the Income share held (as % of total income) of Third 20% of population in Belize to that in Bolivia?
Your answer should be very brief. 0.92. What is the ratio of the Income share held (as % of total income) of Fourth 20% of population in Belize to that in Bolivia?
Your answer should be very brief. 0.88. What is the ratio of the Income share held (as % of total income) of Second 20% of population in Belize to that in Brazil?
Your answer should be compact. 1.12. What is the ratio of the Income share held (as % of total income) in Third 20% of population in Belize to that in Brazil?
Ensure brevity in your answer.  1.02. What is the ratio of the Income share held (as % of total income) in Fourth 20% of population in Belize to that in Brazil?
Your answer should be very brief. 0.92. What is the ratio of the Income share held (as % of total income) in First 20% of population in Belize to that in Bulgaria?
Offer a terse response. 1.75. What is the ratio of the Income share held (as % of total income) in Second 20% of population in Belize to that in Bulgaria?
Make the answer very short. 0.46. What is the ratio of the Income share held (as % of total income) of Third 20% of population in Belize to that in Bulgaria?
Provide a succinct answer. 0.59. What is the ratio of the Income share held (as % of total income) of Fourth 20% of population in Belize to that in Bulgaria?
Provide a short and direct response. 0.76. What is the ratio of the Income share held (as % of total income) of First 20% of population in Belize to that in Canada?
Ensure brevity in your answer.  1.63. What is the ratio of the Income share held (as % of total income) in Second 20% of population in Belize to that in Canada?
Offer a very short reply. 0.49. What is the ratio of the Income share held (as % of total income) of Third 20% of population in Belize to that in Canada?
Make the answer very short. 0.59. What is the ratio of the Income share held (as % of total income) in Fourth 20% of population in Belize to that in Canada?
Your answer should be very brief. 0.72. What is the ratio of the Income share held (as % of total income) of First 20% of population in Bolivia to that in Brazil?
Provide a succinct answer. 0.97. What is the ratio of the Income share held (as % of total income) in Second 20% of population in Bolivia to that in Brazil?
Provide a succinct answer. 1.12. What is the ratio of the Income share held (as % of total income) of Third 20% of population in Bolivia to that in Brazil?
Your answer should be very brief. 1.11. What is the ratio of the Income share held (as % of total income) of Fourth 20% of population in Bolivia to that in Brazil?
Offer a terse response. 1.04. What is the ratio of the Income share held (as % of total income) in First 20% of population in Bolivia to that in Bulgaria?
Provide a short and direct response. 1.68. What is the ratio of the Income share held (as % of total income) in Second 20% of population in Bolivia to that in Bulgaria?
Keep it short and to the point. 0.46. What is the ratio of the Income share held (as % of total income) of Third 20% of population in Bolivia to that in Bulgaria?
Keep it short and to the point. 0.64. What is the ratio of the Income share held (as % of total income) of Fourth 20% of population in Bolivia to that in Bulgaria?
Your response must be concise. 0.86. What is the ratio of the Income share held (as % of total income) in First 20% of population in Bolivia to that in Canada?
Ensure brevity in your answer.  1.57. What is the ratio of the Income share held (as % of total income) in Second 20% of population in Bolivia to that in Canada?
Your answer should be compact. 0.49. What is the ratio of the Income share held (as % of total income) of Third 20% of population in Bolivia to that in Canada?
Ensure brevity in your answer.  0.64. What is the ratio of the Income share held (as % of total income) in Fourth 20% of population in Bolivia to that in Canada?
Provide a succinct answer. 0.82. What is the ratio of the Income share held (as % of total income) of First 20% of population in Brazil to that in Bulgaria?
Offer a terse response. 1.74. What is the ratio of the Income share held (as % of total income) in Second 20% of population in Brazil to that in Bulgaria?
Offer a very short reply. 0.41. What is the ratio of the Income share held (as % of total income) of Third 20% of population in Brazil to that in Bulgaria?
Offer a very short reply. 0.58. What is the ratio of the Income share held (as % of total income) of Fourth 20% of population in Brazil to that in Bulgaria?
Your answer should be very brief. 0.83. What is the ratio of the Income share held (as % of total income) of First 20% of population in Brazil to that in Canada?
Give a very brief answer. 1.62. What is the ratio of the Income share held (as % of total income) in Second 20% of population in Brazil to that in Canada?
Provide a short and direct response. 0.44. What is the ratio of the Income share held (as % of total income) of Third 20% of population in Brazil to that in Canada?
Your response must be concise. 0.58. What is the ratio of the Income share held (as % of total income) of Fourth 20% of population in Brazil to that in Canada?
Provide a succinct answer. 0.79. What is the ratio of the Income share held (as % of total income) in First 20% of population in Bulgaria to that in Canada?
Give a very brief answer. 0.94. What is the ratio of the Income share held (as % of total income) in Second 20% of population in Bulgaria to that in Canada?
Your answer should be compact. 1.08. What is the ratio of the Income share held (as % of total income) of Fourth 20% of population in Bulgaria to that in Canada?
Your response must be concise. 0.95. What is the difference between the highest and the second highest Income share held (as % of total income) of First 20% of population?
Make the answer very short. 0.34. What is the difference between the highest and the second highest Income share held (as % of total income) of Third 20% of population?
Ensure brevity in your answer.  0.06. What is the difference between the highest and the second highest Income share held (as % of total income) of Fourth 20% of population?
Provide a succinct answer. 1.22. What is the difference between the highest and the lowest Income share held (as % of total income) in First 20% of population?
Your answer should be very brief. 27.39. What is the difference between the highest and the lowest Income share held (as % of total income) in Second 20% of population?
Your answer should be compact. 8.2. What is the difference between the highest and the lowest Income share held (as % of total income) of Third 20% of population?
Provide a succinct answer. 7.37. What is the difference between the highest and the lowest Income share held (as % of total income) of Fourth 20% of population?
Offer a very short reply. 6.47. 